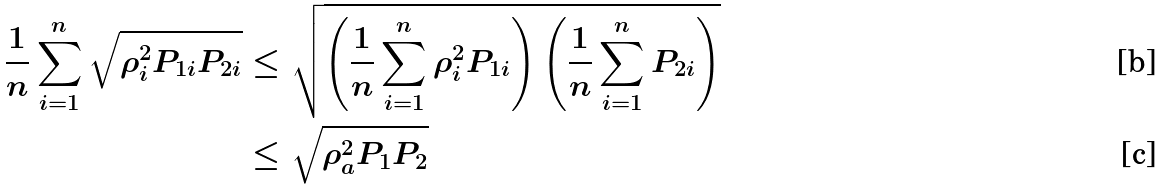Convert formula to latex. <formula><loc_0><loc_0><loc_500><loc_500>\frac { 1 } { n } \sum _ { i = 1 } ^ { n } \sqrt { \rho _ { i } ^ { 2 } P _ { 1 i } P _ { 2 i } } & \leq \sqrt { \left ( \frac { 1 } { n } \sum _ { i = 1 } ^ { n } \rho _ { i } ^ { 2 } P _ { 1 i } \right ) \left ( \frac { 1 } { n } \sum _ { i = 1 } ^ { n } P _ { 2 i } \right ) } \\ & \leq \sqrt { \rho _ { a } ^ { 2 } P _ { 1 } P _ { 2 } }</formula> 